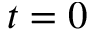Convert formula to latex. <formula><loc_0><loc_0><loc_500><loc_500>t = 0</formula> 